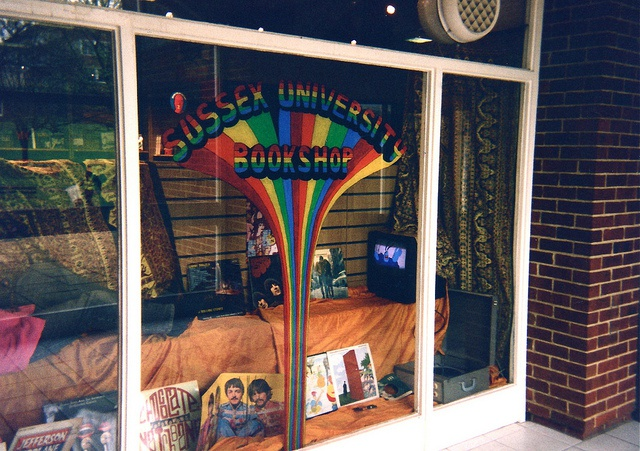Describe the objects in this image and their specific colors. I can see tv in tan, black, navy, violet, and blue tones, people in tan, gray, blue, and navy tones, people in tan, brown, purple, and maroon tones, people in tan, black, maroon, and brown tones, and people in tan, navy, darkgray, gray, and black tones in this image. 